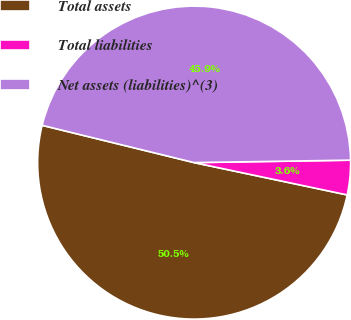Convert chart to OTSL. <chart><loc_0><loc_0><loc_500><loc_500><pie_chart><fcel>Total assets<fcel>Total liabilities<fcel>Net assets (liabilities)^(3)<nl><fcel>50.51%<fcel>3.56%<fcel>45.92%<nl></chart> 